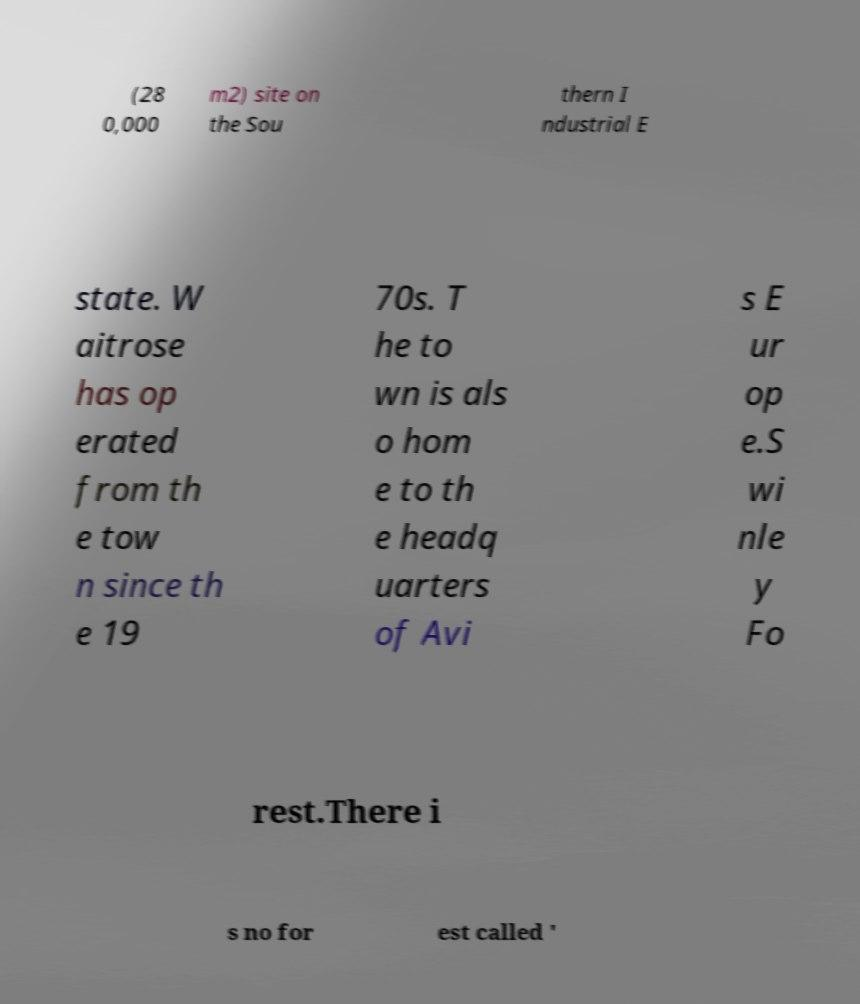I need the written content from this picture converted into text. Can you do that? (28 0,000 m2) site on the Sou thern I ndustrial E state. W aitrose has op erated from th e tow n since th e 19 70s. T he to wn is als o hom e to th e headq uarters of Avi s E ur op e.S wi nle y Fo rest.There i s no for est called ' 